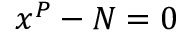<formula> <loc_0><loc_0><loc_500><loc_500>\ x ^ { P } - N = 0</formula> 